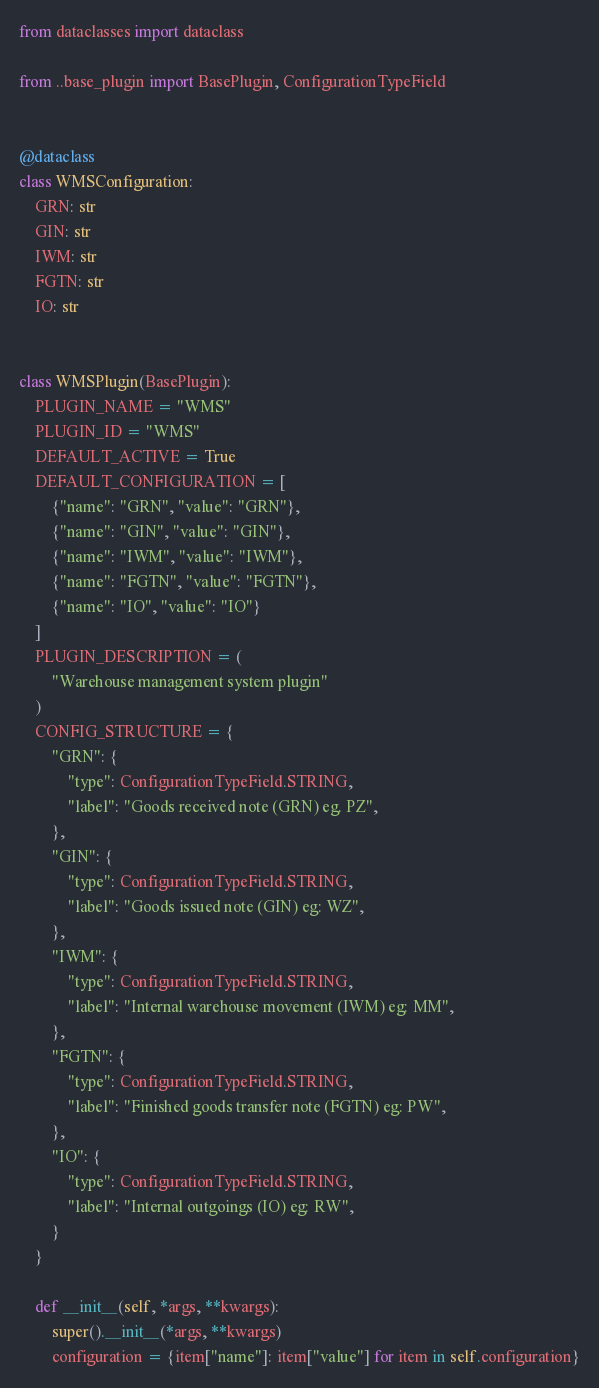<code> <loc_0><loc_0><loc_500><loc_500><_Python_>from dataclasses import dataclass

from ..base_plugin import BasePlugin, ConfigurationTypeField


@dataclass
class WMSConfiguration:
    GRN: str
    GIN: str
    IWM: str
    FGTN: str
    IO: str


class WMSPlugin(BasePlugin):
    PLUGIN_NAME = "WMS"
    PLUGIN_ID = "WMS"
    DEFAULT_ACTIVE = True
    DEFAULT_CONFIGURATION = [
        {"name": "GRN", "value": "GRN"},
        {"name": "GIN", "value": "GIN"},
        {"name": "IWM", "value": "IWM"},
        {"name": "FGTN", "value": "FGTN"},
        {"name": "IO", "value": "IO"}
    ]
    PLUGIN_DESCRIPTION = (
        "Warehouse management system plugin"
    )
    CONFIG_STRUCTURE = {
        "GRN": {
            "type": ConfigurationTypeField.STRING,
            "label": "Goods received note (GRN) eg. PZ",
        },
        "GIN": {
            "type": ConfigurationTypeField.STRING,
            "label": "Goods issued note (GIN) eg: WZ",
        },
        "IWM": {
            "type": ConfigurationTypeField.STRING,
            "label": "Internal warehouse movement (IWM) eg: MM",
        },
        "FGTN": {
            "type": ConfigurationTypeField.STRING,
            "label": "Finished goods transfer note (FGTN) eg: PW",
        },
        "IO": {
            "type": ConfigurationTypeField.STRING,
            "label": "Internal outgoings (IO) eg: RW",
        }
    }

    def __init__(self, *args, **kwargs):
        super().__init__(*args, **kwargs)
        configuration = {item["name"]: item["value"] for item in self.configuration}
</code> 